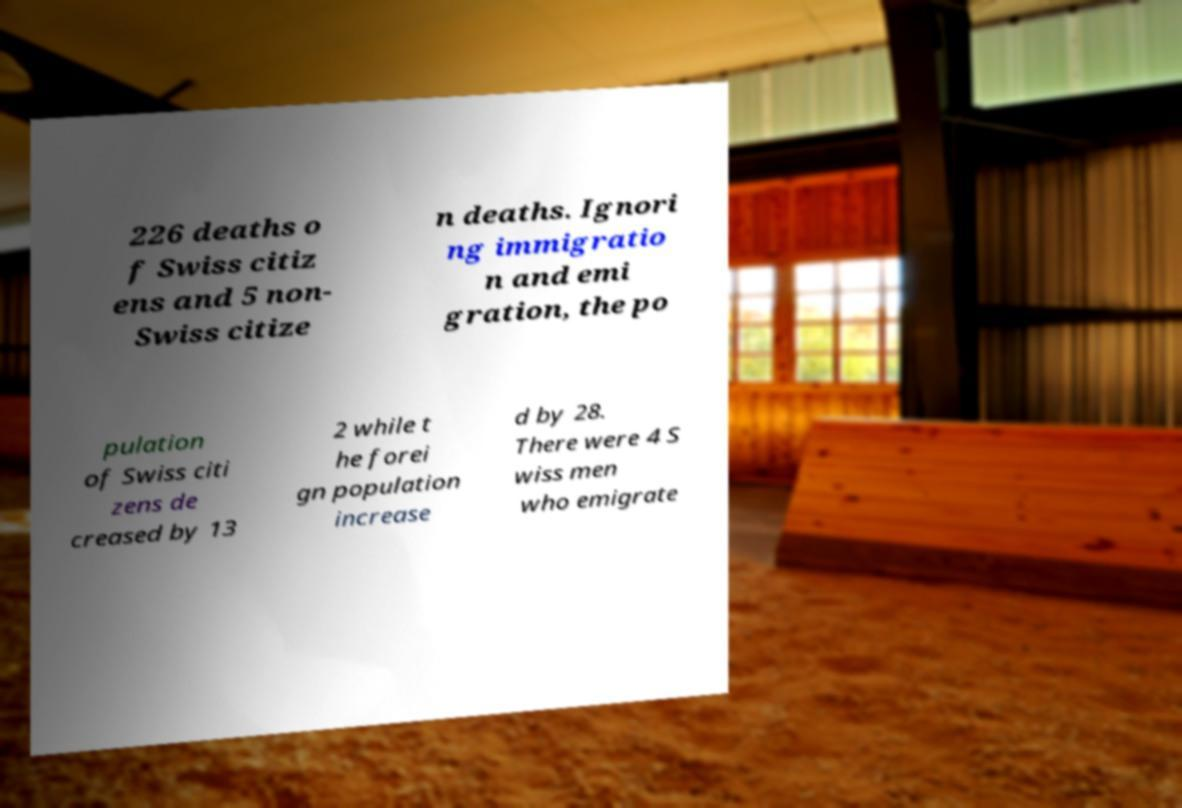Please identify and transcribe the text found in this image. 226 deaths o f Swiss citiz ens and 5 non- Swiss citize n deaths. Ignori ng immigratio n and emi gration, the po pulation of Swiss citi zens de creased by 13 2 while t he forei gn population increase d by 28. There were 4 S wiss men who emigrate 